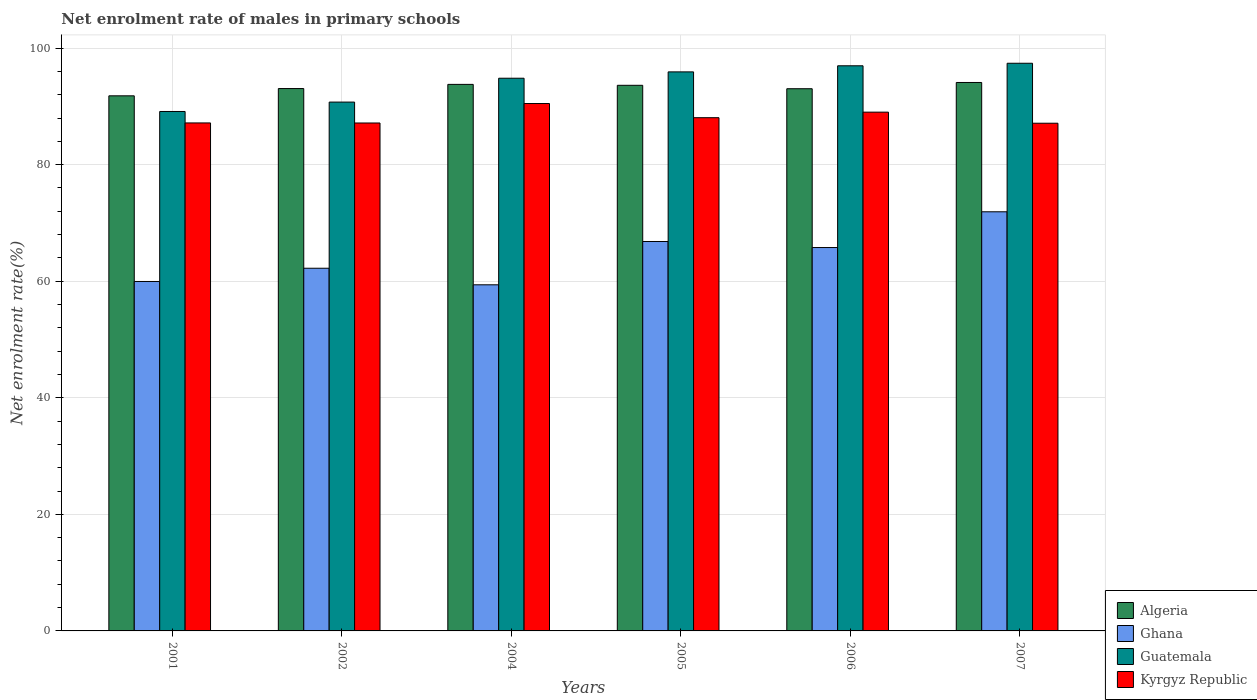How many groups of bars are there?
Make the answer very short. 6. Are the number of bars per tick equal to the number of legend labels?
Your answer should be compact. Yes. Are the number of bars on each tick of the X-axis equal?
Provide a short and direct response. Yes. How many bars are there on the 6th tick from the right?
Give a very brief answer. 4. What is the label of the 5th group of bars from the left?
Provide a short and direct response. 2006. In how many cases, is the number of bars for a given year not equal to the number of legend labels?
Ensure brevity in your answer.  0. What is the net enrolment rate of males in primary schools in Algeria in 2005?
Make the answer very short. 93.62. Across all years, what is the maximum net enrolment rate of males in primary schools in Algeria?
Make the answer very short. 94.11. Across all years, what is the minimum net enrolment rate of males in primary schools in Algeria?
Provide a short and direct response. 91.82. What is the total net enrolment rate of males in primary schools in Guatemala in the graph?
Give a very brief answer. 565. What is the difference between the net enrolment rate of males in primary schools in Kyrgyz Republic in 2004 and that in 2007?
Your answer should be compact. 3.38. What is the difference between the net enrolment rate of males in primary schools in Guatemala in 2001 and the net enrolment rate of males in primary schools in Kyrgyz Republic in 2004?
Your answer should be compact. -1.37. What is the average net enrolment rate of males in primary schools in Ghana per year?
Your answer should be very brief. 64.35. In the year 2004, what is the difference between the net enrolment rate of males in primary schools in Algeria and net enrolment rate of males in primary schools in Kyrgyz Republic?
Give a very brief answer. 3.28. What is the ratio of the net enrolment rate of males in primary schools in Algeria in 2002 to that in 2005?
Your answer should be compact. 0.99. Is the net enrolment rate of males in primary schools in Kyrgyz Republic in 2001 less than that in 2006?
Keep it short and to the point. Yes. Is the difference between the net enrolment rate of males in primary schools in Algeria in 2006 and 2007 greater than the difference between the net enrolment rate of males in primary schools in Kyrgyz Republic in 2006 and 2007?
Your answer should be compact. No. What is the difference between the highest and the second highest net enrolment rate of males in primary schools in Ghana?
Your response must be concise. 5.09. What is the difference between the highest and the lowest net enrolment rate of males in primary schools in Kyrgyz Republic?
Offer a terse response. 3.38. In how many years, is the net enrolment rate of males in primary schools in Ghana greater than the average net enrolment rate of males in primary schools in Ghana taken over all years?
Your response must be concise. 3. Is the sum of the net enrolment rate of males in primary schools in Algeria in 2001 and 2006 greater than the maximum net enrolment rate of males in primary schools in Kyrgyz Republic across all years?
Ensure brevity in your answer.  Yes. Is it the case that in every year, the sum of the net enrolment rate of males in primary schools in Guatemala and net enrolment rate of males in primary schools in Algeria is greater than the sum of net enrolment rate of males in primary schools in Kyrgyz Republic and net enrolment rate of males in primary schools in Ghana?
Your answer should be very brief. Yes. What does the 4th bar from the left in 2004 represents?
Your response must be concise. Kyrgyz Republic. What does the 2nd bar from the right in 2006 represents?
Make the answer very short. Guatemala. Is it the case that in every year, the sum of the net enrolment rate of males in primary schools in Algeria and net enrolment rate of males in primary schools in Guatemala is greater than the net enrolment rate of males in primary schools in Kyrgyz Republic?
Make the answer very short. Yes. How many bars are there?
Keep it short and to the point. 24. How many years are there in the graph?
Provide a short and direct response. 6. What is the difference between two consecutive major ticks on the Y-axis?
Ensure brevity in your answer.  20. Does the graph contain any zero values?
Your answer should be very brief. No. Where does the legend appear in the graph?
Ensure brevity in your answer.  Bottom right. How are the legend labels stacked?
Offer a very short reply. Vertical. What is the title of the graph?
Keep it short and to the point. Net enrolment rate of males in primary schools. Does "Vanuatu" appear as one of the legend labels in the graph?
Offer a terse response. No. What is the label or title of the Y-axis?
Give a very brief answer. Net enrolment rate(%). What is the Net enrolment rate(%) in Algeria in 2001?
Give a very brief answer. 91.82. What is the Net enrolment rate(%) in Ghana in 2001?
Offer a very short reply. 59.96. What is the Net enrolment rate(%) of Guatemala in 2001?
Keep it short and to the point. 89.13. What is the Net enrolment rate(%) in Kyrgyz Republic in 2001?
Provide a succinct answer. 87.16. What is the Net enrolment rate(%) in Algeria in 2002?
Offer a terse response. 93.06. What is the Net enrolment rate(%) of Ghana in 2002?
Ensure brevity in your answer.  62.23. What is the Net enrolment rate(%) in Guatemala in 2002?
Provide a succinct answer. 90.74. What is the Net enrolment rate(%) of Kyrgyz Republic in 2002?
Offer a very short reply. 87.15. What is the Net enrolment rate(%) of Algeria in 2004?
Make the answer very short. 93.78. What is the Net enrolment rate(%) in Ghana in 2004?
Make the answer very short. 59.39. What is the Net enrolment rate(%) of Guatemala in 2004?
Offer a very short reply. 94.83. What is the Net enrolment rate(%) of Kyrgyz Republic in 2004?
Provide a short and direct response. 90.5. What is the Net enrolment rate(%) of Algeria in 2005?
Give a very brief answer. 93.62. What is the Net enrolment rate(%) of Ghana in 2005?
Offer a terse response. 66.82. What is the Net enrolment rate(%) of Guatemala in 2005?
Keep it short and to the point. 95.92. What is the Net enrolment rate(%) in Kyrgyz Republic in 2005?
Your answer should be compact. 88.06. What is the Net enrolment rate(%) of Algeria in 2006?
Provide a short and direct response. 93.03. What is the Net enrolment rate(%) in Ghana in 2006?
Provide a short and direct response. 65.78. What is the Net enrolment rate(%) in Guatemala in 2006?
Ensure brevity in your answer.  96.97. What is the Net enrolment rate(%) in Kyrgyz Republic in 2006?
Your answer should be compact. 89.01. What is the Net enrolment rate(%) of Algeria in 2007?
Keep it short and to the point. 94.11. What is the Net enrolment rate(%) in Ghana in 2007?
Your answer should be very brief. 71.92. What is the Net enrolment rate(%) in Guatemala in 2007?
Offer a terse response. 97.4. What is the Net enrolment rate(%) of Kyrgyz Republic in 2007?
Make the answer very short. 87.11. Across all years, what is the maximum Net enrolment rate(%) in Algeria?
Your answer should be compact. 94.11. Across all years, what is the maximum Net enrolment rate(%) in Ghana?
Your answer should be very brief. 71.92. Across all years, what is the maximum Net enrolment rate(%) of Guatemala?
Your answer should be very brief. 97.4. Across all years, what is the maximum Net enrolment rate(%) in Kyrgyz Republic?
Your answer should be compact. 90.5. Across all years, what is the minimum Net enrolment rate(%) of Algeria?
Keep it short and to the point. 91.82. Across all years, what is the minimum Net enrolment rate(%) in Ghana?
Ensure brevity in your answer.  59.39. Across all years, what is the minimum Net enrolment rate(%) of Guatemala?
Ensure brevity in your answer.  89.13. Across all years, what is the minimum Net enrolment rate(%) of Kyrgyz Republic?
Make the answer very short. 87.11. What is the total Net enrolment rate(%) in Algeria in the graph?
Keep it short and to the point. 559.42. What is the total Net enrolment rate(%) in Ghana in the graph?
Provide a short and direct response. 386.1. What is the total Net enrolment rate(%) in Guatemala in the graph?
Ensure brevity in your answer.  565. What is the total Net enrolment rate(%) in Kyrgyz Republic in the graph?
Your answer should be very brief. 529. What is the difference between the Net enrolment rate(%) in Algeria in 2001 and that in 2002?
Your response must be concise. -1.25. What is the difference between the Net enrolment rate(%) of Ghana in 2001 and that in 2002?
Your answer should be very brief. -2.27. What is the difference between the Net enrolment rate(%) in Guatemala in 2001 and that in 2002?
Make the answer very short. -1.61. What is the difference between the Net enrolment rate(%) in Kyrgyz Republic in 2001 and that in 2002?
Your response must be concise. 0.01. What is the difference between the Net enrolment rate(%) of Algeria in 2001 and that in 2004?
Offer a terse response. -1.96. What is the difference between the Net enrolment rate(%) of Ghana in 2001 and that in 2004?
Provide a succinct answer. 0.57. What is the difference between the Net enrolment rate(%) in Guatemala in 2001 and that in 2004?
Provide a succinct answer. -5.71. What is the difference between the Net enrolment rate(%) of Kyrgyz Republic in 2001 and that in 2004?
Offer a very short reply. -3.33. What is the difference between the Net enrolment rate(%) in Algeria in 2001 and that in 2005?
Make the answer very short. -1.81. What is the difference between the Net enrolment rate(%) in Ghana in 2001 and that in 2005?
Offer a terse response. -6.86. What is the difference between the Net enrolment rate(%) in Guatemala in 2001 and that in 2005?
Offer a very short reply. -6.8. What is the difference between the Net enrolment rate(%) in Kyrgyz Republic in 2001 and that in 2005?
Keep it short and to the point. -0.9. What is the difference between the Net enrolment rate(%) of Algeria in 2001 and that in 2006?
Offer a very short reply. -1.22. What is the difference between the Net enrolment rate(%) in Ghana in 2001 and that in 2006?
Give a very brief answer. -5.82. What is the difference between the Net enrolment rate(%) of Guatemala in 2001 and that in 2006?
Your answer should be compact. -7.84. What is the difference between the Net enrolment rate(%) in Kyrgyz Republic in 2001 and that in 2006?
Offer a very short reply. -1.85. What is the difference between the Net enrolment rate(%) of Algeria in 2001 and that in 2007?
Your answer should be very brief. -2.29. What is the difference between the Net enrolment rate(%) in Ghana in 2001 and that in 2007?
Your answer should be compact. -11.96. What is the difference between the Net enrolment rate(%) of Guatemala in 2001 and that in 2007?
Ensure brevity in your answer.  -8.27. What is the difference between the Net enrolment rate(%) of Kyrgyz Republic in 2001 and that in 2007?
Give a very brief answer. 0.05. What is the difference between the Net enrolment rate(%) of Algeria in 2002 and that in 2004?
Provide a short and direct response. -0.72. What is the difference between the Net enrolment rate(%) of Ghana in 2002 and that in 2004?
Your response must be concise. 2.84. What is the difference between the Net enrolment rate(%) in Guatemala in 2002 and that in 2004?
Provide a succinct answer. -4.09. What is the difference between the Net enrolment rate(%) of Kyrgyz Republic in 2002 and that in 2004?
Your response must be concise. -3.34. What is the difference between the Net enrolment rate(%) of Algeria in 2002 and that in 2005?
Provide a succinct answer. -0.56. What is the difference between the Net enrolment rate(%) of Ghana in 2002 and that in 2005?
Your response must be concise. -4.59. What is the difference between the Net enrolment rate(%) in Guatemala in 2002 and that in 2005?
Your response must be concise. -5.18. What is the difference between the Net enrolment rate(%) of Kyrgyz Republic in 2002 and that in 2005?
Provide a succinct answer. -0.91. What is the difference between the Net enrolment rate(%) of Algeria in 2002 and that in 2006?
Provide a succinct answer. 0.03. What is the difference between the Net enrolment rate(%) of Ghana in 2002 and that in 2006?
Offer a very short reply. -3.55. What is the difference between the Net enrolment rate(%) in Guatemala in 2002 and that in 2006?
Make the answer very short. -6.23. What is the difference between the Net enrolment rate(%) of Kyrgyz Republic in 2002 and that in 2006?
Give a very brief answer. -1.86. What is the difference between the Net enrolment rate(%) of Algeria in 2002 and that in 2007?
Ensure brevity in your answer.  -1.04. What is the difference between the Net enrolment rate(%) in Ghana in 2002 and that in 2007?
Offer a very short reply. -9.68. What is the difference between the Net enrolment rate(%) in Guatemala in 2002 and that in 2007?
Give a very brief answer. -6.66. What is the difference between the Net enrolment rate(%) in Kyrgyz Republic in 2002 and that in 2007?
Your answer should be very brief. 0.04. What is the difference between the Net enrolment rate(%) of Algeria in 2004 and that in 2005?
Give a very brief answer. 0.16. What is the difference between the Net enrolment rate(%) in Ghana in 2004 and that in 2005?
Ensure brevity in your answer.  -7.43. What is the difference between the Net enrolment rate(%) in Guatemala in 2004 and that in 2005?
Provide a succinct answer. -1.09. What is the difference between the Net enrolment rate(%) in Kyrgyz Republic in 2004 and that in 2005?
Your answer should be very brief. 2.43. What is the difference between the Net enrolment rate(%) of Algeria in 2004 and that in 2006?
Provide a short and direct response. 0.75. What is the difference between the Net enrolment rate(%) in Ghana in 2004 and that in 2006?
Make the answer very short. -6.39. What is the difference between the Net enrolment rate(%) in Guatemala in 2004 and that in 2006?
Provide a short and direct response. -2.14. What is the difference between the Net enrolment rate(%) of Kyrgyz Republic in 2004 and that in 2006?
Your response must be concise. 1.48. What is the difference between the Net enrolment rate(%) in Algeria in 2004 and that in 2007?
Provide a succinct answer. -0.33. What is the difference between the Net enrolment rate(%) in Ghana in 2004 and that in 2007?
Your response must be concise. -12.53. What is the difference between the Net enrolment rate(%) of Guatemala in 2004 and that in 2007?
Offer a terse response. -2.57. What is the difference between the Net enrolment rate(%) in Kyrgyz Republic in 2004 and that in 2007?
Keep it short and to the point. 3.38. What is the difference between the Net enrolment rate(%) of Algeria in 2005 and that in 2006?
Offer a very short reply. 0.59. What is the difference between the Net enrolment rate(%) of Ghana in 2005 and that in 2006?
Give a very brief answer. 1.04. What is the difference between the Net enrolment rate(%) in Guatemala in 2005 and that in 2006?
Your answer should be compact. -1.05. What is the difference between the Net enrolment rate(%) in Kyrgyz Republic in 2005 and that in 2006?
Your answer should be compact. -0.95. What is the difference between the Net enrolment rate(%) in Algeria in 2005 and that in 2007?
Offer a terse response. -0.48. What is the difference between the Net enrolment rate(%) of Ghana in 2005 and that in 2007?
Make the answer very short. -5.09. What is the difference between the Net enrolment rate(%) in Guatemala in 2005 and that in 2007?
Provide a short and direct response. -1.48. What is the difference between the Net enrolment rate(%) of Kyrgyz Republic in 2005 and that in 2007?
Make the answer very short. 0.95. What is the difference between the Net enrolment rate(%) in Algeria in 2006 and that in 2007?
Your answer should be compact. -1.07. What is the difference between the Net enrolment rate(%) in Ghana in 2006 and that in 2007?
Your response must be concise. -6.13. What is the difference between the Net enrolment rate(%) in Guatemala in 2006 and that in 2007?
Your answer should be very brief. -0.43. What is the difference between the Net enrolment rate(%) of Kyrgyz Republic in 2006 and that in 2007?
Make the answer very short. 1.9. What is the difference between the Net enrolment rate(%) in Algeria in 2001 and the Net enrolment rate(%) in Ghana in 2002?
Keep it short and to the point. 29.58. What is the difference between the Net enrolment rate(%) of Algeria in 2001 and the Net enrolment rate(%) of Guatemala in 2002?
Your answer should be very brief. 1.07. What is the difference between the Net enrolment rate(%) in Algeria in 2001 and the Net enrolment rate(%) in Kyrgyz Republic in 2002?
Provide a short and direct response. 4.66. What is the difference between the Net enrolment rate(%) of Ghana in 2001 and the Net enrolment rate(%) of Guatemala in 2002?
Ensure brevity in your answer.  -30.78. What is the difference between the Net enrolment rate(%) in Ghana in 2001 and the Net enrolment rate(%) in Kyrgyz Republic in 2002?
Offer a terse response. -27.19. What is the difference between the Net enrolment rate(%) of Guatemala in 2001 and the Net enrolment rate(%) of Kyrgyz Republic in 2002?
Your answer should be compact. 1.97. What is the difference between the Net enrolment rate(%) in Algeria in 2001 and the Net enrolment rate(%) in Ghana in 2004?
Provide a short and direct response. 32.43. What is the difference between the Net enrolment rate(%) of Algeria in 2001 and the Net enrolment rate(%) of Guatemala in 2004?
Your answer should be very brief. -3.02. What is the difference between the Net enrolment rate(%) in Algeria in 2001 and the Net enrolment rate(%) in Kyrgyz Republic in 2004?
Give a very brief answer. 1.32. What is the difference between the Net enrolment rate(%) in Ghana in 2001 and the Net enrolment rate(%) in Guatemala in 2004?
Ensure brevity in your answer.  -34.87. What is the difference between the Net enrolment rate(%) of Ghana in 2001 and the Net enrolment rate(%) of Kyrgyz Republic in 2004?
Keep it short and to the point. -30.53. What is the difference between the Net enrolment rate(%) in Guatemala in 2001 and the Net enrolment rate(%) in Kyrgyz Republic in 2004?
Provide a short and direct response. -1.37. What is the difference between the Net enrolment rate(%) of Algeria in 2001 and the Net enrolment rate(%) of Ghana in 2005?
Provide a short and direct response. 24.99. What is the difference between the Net enrolment rate(%) of Algeria in 2001 and the Net enrolment rate(%) of Guatemala in 2005?
Your answer should be very brief. -4.11. What is the difference between the Net enrolment rate(%) in Algeria in 2001 and the Net enrolment rate(%) in Kyrgyz Republic in 2005?
Make the answer very short. 3.75. What is the difference between the Net enrolment rate(%) of Ghana in 2001 and the Net enrolment rate(%) of Guatemala in 2005?
Your response must be concise. -35.96. What is the difference between the Net enrolment rate(%) of Ghana in 2001 and the Net enrolment rate(%) of Kyrgyz Republic in 2005?
Your answer should be very brief. -28.1. What is the difference between the Net enrolment rate(%) of Guatemala in 2001 and the Net enrolment rate(%) of Kyrgyz Republic in 2005?
Give a very brief answer. 1.06. What is the difference between the Net enrolment rate(%) of Algeria in 2001 and the Net enrolment rate(%) of Ghana in 2006?
Keep it short and to the point. 26.03. What is the difference between the Net enrolment rate(%) in Algeria in 2001 and the Net enrolment rate(%) in Guatemala in 2006?
Your answer should be very brief. -5.15. What is the difference between the Net enrolment rate(%) of Algeria in 2001 and the Net enrolment rate(%) of Kyrgyz Republic in 2006?
Provide a short and direct response. 2.8. What is the difference between the Net enrolment rate(%) in Ghana in 2001 and the Net enrolment rate(%) in Guatemala in 2006?
Keep it short and to the point. -37.01. What is the difference between the Net enrolment rate(%) in Ghana in 2001 and the Net enrolment rate(%) in Kyrgyz Republic in 2006?
Give a very brief answer. -29.05. What is the difference between the Net enrolment rate(%) of Guatemala in 2001 and the Net enrolment rate(%) of Kyrgyz Republic in 2006?
Your response must be concise. 0.11. What is the difference between the Net enrolment rate(%) of Algeria in 2001 and the Net enrolment rate(%) of Ghana in 2007?
Keep it short and to the point. 19.9. What is the difference between the Net enrolment rate(%) in Algeria in 2001 and the Net enrolment rate(%) in Guatemala in 2007?
Offer a terse response. -5.59. What is the difference between the Net enrolment rate(%) in Algeria in 2001 and the Net enrolment rate(%) in Kyrgyz Republic in 2007?
Your response must be concise. 4.7. What is the difference between the Net enrolment rate(%) in Ghana in 2001 and the Net enrolment rate(%) in Guatemala in 2007?
Ensure brevity in your answer.  -37.44. What is the difference between the Net enrolment rate(%) in Ghana in 2001 and the Net enrolment rate(%) in Kyrgyz Republic in 2007?
Your answer should be very brief. -27.15. What is the difference between the Net enrolment rate(%) of Guatemala in 2001 and the Net enrolment rate(%) of Kyrgyz Republic in 2007?
Offer a terse response. 2.02. What is the difference between the Net enrolment rate(%) of Algeria in 2002 and the Net enrolment rate(%) of Ghana in 2004?
Your response must be concise. 33.67. What is the difference between the Net enrolment rate(%) in Algeria in 2002 and the Net enrolment rate(%) in Guatemala in 2004?
Make the answer very short. -1.77. What is the difference between the Net enrolment rate(%) in Algeria in 2002 and the Net enrolment rate(%) in Kyrgyz Republic in 2004?
Your response must be concise. 2.57. What is the difference between the Net enrolment rate(%) of Ghana in 2002 and the Net enrolment rate(%) of Guatemala in 2004?
Provide a succinct answer. -32.6. What is the difference between the Net enrolment rate(%) in Ghana in 2002 and the Net enrolment rate(%) in Kyrgyz Republic in 2004?
Offer a very short reply. -28.26. What is the difference between the Net enrolment rate(%) of Guatemala in 2002 and the Net enrolment rate(%) of Kyrgyz Republic in 2004?
Your response must be concise. 0.25. What is the difference between the Net enrolment rate(%) of Algeria in 2002 and the Net enrolment rate(%) of Ghana in 2005?
Give a very brief answer. 26.24. What is the difference between the Net enrolment rate(%) of Algeria in 2002 and the Net enrolment rate(%) of Guatemala in 2005?
Your response must be concise. -2.86. What is the difference between the Net enrolment rate(%) of Algeria in 2002 and the Net enrolment rate(%) of Kyrgyz Republic in 2005?
Offer a very short reply. 5. What is the difference between the Net enrolment rate(%) in Ghana in 2002 and the Net enrolment rate(%) in Guatemala in 2005?
Keep it short and to the point. -33.69. What is the difference between the Net enrolment rate(%) of Ghana in 2002 and the Net enrolment rate(%) of Kyrgyz Republic in 2005?
Keep it short and to the point. -25.83. What is the difference between the Net enrolment rate(%) of Guatemala in 2002 and the Net enrolment rate(%) of Kyrgyz Republic in 2005?
Your response must be concise. 2.68. What is the difference between the Net enrolment rate(%) of Algeria in 2002 and the Net enrolment rate(%) of Ghana in 2006?
Your answer should be compact. 27.28. What is the difference between the Net enrolment rate(%) in Algeria in 2002 and the Net enrolment rate(%) in Guatemala in 2006?
Give a very brief answer. -3.91. What is the difference between the Net enrolment rate(%) in Algeria in 2002 and the Net enrolment rate(%) in Kyrgyz Republic in 2006?
Offer a terse response. 4.05. What is the difference between the Net enrolment rate(%) in Ghana in 2002 and the Net enrolment rate(%) in Guatemala in 2006?
Your response must be concise. -34.74. What is the difference between the Net enrolment rate(%) in Ghana in 2002 and the Net enrolment rate(%) in Kyrgyz Republic in 2006?
Offer a terse response. -26.78. What is the difference between the Net enrolment rate(%) in Guatemala in 2002 and the Net enrolment rate(%) in Kyrgyz Republic in 2006?
Keep it short and to the point. 1.73. What is the difference between the Net enrolment rate(%) in Algeria in 2002 and the Net enrolment rate(%) in Ghana in 2007?
Keep it short and to the point. 21.15. What is the difference between the Net enrolment rate(%) in Algeria in 2002 and the Net enrolment rate(%) in Guatemala in 2007?
Give a very brief answer. -4.34. What is the difference between the Net enrolment rate(%) of Algeria in 2002 and the Net enrolment rate(%) of Kyrgyz Republic in 2007?
Provide a short and direct response. 5.95. What is the difference between the Net enrolment rate(%) in Ghana in 2002 and the Net enrolment rate(%) in Guatemala in 2007?
Your answer should be compact. -35.17. What is the difference between the Net enrolment rate(%) in Ghana in 2002 and the Net enrolment rate(%) in Kyrgyz Republic in 2007?
Offer a very short reply. -24.88. What is the difference between the Net enrolment rate(%) of Guatemala in 2002 and the Net enrolment rate(%) of Kyrgyz Republic in 2007?
Offer a very short reply. 3.63. What is the difference between the Net enrolment rate(%) of Algeria in 2004 and the Net enrolment rate(%) of Ghana in 2005?
Your answer should be compact. 26.96. What is the difference between the Net enrolment rate(%) in Algeria in 2004 and the Net enrolment rate(%) in Guatemala in 2005?
Provide a succinct answer. -2.14. What is the difference between the Net enrolment rate(%) of Algeria in 2004 and the Net enrolment rate(%) of Kyrgyz Republic in 2005?
Keep it short and to the point. 5.72. What is the difference between the Net enrolment rate(%) of Ghana in 2004 and the Net enrolment rate(%) of Guatemala in 2005?
Give a very brief answer. -36.53. What is the difference between the Net enrolment rate(%) of Ghana in 2004 and the Net enrolment rate(%) of Kyrgyz Republic in 2005?
Make the answer very short. -28.67. What is the difference between the Net enrolment rate(%) of Guatemala in 2004 and the Net enrolment rate(%) of Kyrgyz Republic in 2005?
Ensure brevity in your answer.  6.77. What is the difference between the Net enrolment rate(%) of Algeria in 2004 and the Net enrolment rate(%) of Ghana in 2006?
Make the answer very short. 28. What is the difference between the Net enrolment rate(%) in Algeria in 2004 and the Net enrolment rate(%) in Guatemala in 2006?
Offer a terse response. -3.19. What is the difference between the Net enrolment rate(%) in Algeria in 2004 and the Net enrolment rate(%) in Kyrgyz Republic in 2006?
Ensure brevity in your answer.  4.77. What is the difference between the Net enrolment rate(%) in Ghana in 2004 and the Net enrolment rate(%) in Guatemala in 2006?
Provide a short and direct response. -37.58. What is the difference between the Net enrolment rate(%) of Ghana in 2004 and the Net enrolment rate(%) of Kyrgyz Republic in 2006?
Provide a short and direct response. -29.62. What is the difference between the Net enrolment rate(%) of Guatemala in 2004 and the Net enrolment rate(%) of Kyrgyz Republic in 2006?
Ensure brevity in your answer.  5.82. What is the difference between the Net enrolment rate(%) in Algeria in 2004 and the Net enrolment rate(%) in Ghana in 2007?
Make the answer very short. 21.86. What is the difference between the Net enrolment rate(%) in Algeria in 2004 and the Net enrolment rate(%) in Guatemala in 2007?
Provide a short and direct response. -3.62. What is the difference between the Net enrolment rate(%) of Ghana in 2004 and the Net enrolment rate(%) of Guatemala in 2007?
Provide a short and direct response. -38.01. What is the difference between the Net enrolment rate(%) of Ghana in 2004 and the Net enrolment rate(%) of Kyrgyz Republic in 2007?
Make the answer very short. -27.72. What is the difference between the Net enrolment rate(%) in Guatemala in 2004 and the Net enrolment rate(%) in Kyrgyz Republic in 2007?
Your answer should be very brief. 7.72. What is the difference between the Net enrolment rate(%) of Algeria in 2005 and the Net enrolment rate(%) of Ghana in 2006?
Provide a short and direct response. 27.84. What is the difference between the Net enrolment rate(%) in Algeria in 2005 and the Net enrolment rate(%) in Guatemala in 2006?
Ensure brevity in your answer.  -3.35. What is the difference between the Net enrolment rate(%) in Algeria in 2005 and the Net enrolment rate(%) in Kyrgyz Republic in 2006?
Keep it short and to the point. 4.61. What is the difference between the Net enrolment rate(%) in Ghana in 2005 and the Net enrolment rate(%) in Guatemala in 2006?
Keep it short and to the point. -30.15. What is the difference between the Net enrolment rate(%) in Ghana in 2005 and the Net enrolment rate(%) in Kyrgyz Republic in 2006?
Offer a very short reply. -22.19. What is the difference between the Net enrolment rate(%) in Guatemala in 2005 and the Net enrolment rate(%) in Kyrgyz Republic in 2006?
Give a very brief answer. 6.91. What is the difference between the Net enrolment rate(%) in Algeria in 2005 and the Net enrolment rate(%) in Ghana in 2007?
Provide a succinct answer. 21.7. What is the difference between the Net enrolment rate(%) of Algeria in 2005 and the Net enrolment rate(%) of Guatemala in 2007?
Your response must be concise. -3.78. What is the difference between the Net enrolment rate(%) of Algeria in 2005 and the Net enrolment rate(%) of Kyrgyz Republic in 2007?
Your response must be concise. 6.51. What is the difference between the Net enrolment rate(%) of Ghana in 2005 and the Net enrolment rate(%) of Guatemala in 2007?
Ensure brevity in your answer.  -30.58. What is the difference between the Net enrolment rate(%) of Ghana in 2005 and the Net enrolment rate(%) of Kyrgyz Republic in 2007?
Keep it short and to the point. -20.29. What is the difference between the Net enrolment rate(%) of Guatemala in 2005 and the Net enrolment rate(%) of Kyrgyz Republic in 2007?
Make the answer very short. 8.81. What is the difference between the Net enrolment rate(%) of Algeria in 2006 and the Net enrolment rate(%) of Ghana in 2007?
Keep it short and to the point. 21.12. What is the difference between the Net enrolment rate(%) of Algeria in 2006 and the Net enrolment rate(%) of Guatemala in 2007?
Your response must be concise. -4.37. What is the difference between the Net enrolment rate(%) of Algeria in 2006 and the Net enrolment rate(%) of Kyrgyz Republic in 2007?
Give a very brief answer. 5.92. What is the difference between the Net enrolment rate(%) in Ghana in 2006 and the Net enrolment rate(%) in Guatemala in 2007?
Give a very brief answer. -31.62. What is the difference between the Net enrolment rate(%) in Ghana in 2006 and the Net enrolment rate(%) in Kyrgyz Republic in 2007?
Provide a short and direct response. -21.33. What is the difference between the Net enrolment rate(%) in Guatemala in 2006 and the Net enrolment rate(%) in Kyrgyz Republic in 2007?
Provide a short and direct response. 9.86. What is the average Net enrolment rate(%) in Algeria per year?
Your answer should be very brief. 93.24. What is the average Net enrolment rate(%) in Ghana per year?
Make the answer very short. 64.35. What is the average Net enrolment rate(%) of Guatemala per year?
Your answer should be very brief. 94.17. What is the average Net enrolment rate(%) in Kyrgyz Republic per year?
Offer a terse response. 88.17. In the year 2001, what is the difference between the Net enrolment rate(%) of Algeria and Net enrolment rate(%) of Ghana?
Your answer should be very brief. 31.85. In the year 2001, what is the difference between the Net enrolment rate(%) of Algeria and Net enrolment rate(%) of Guatemala?
Make the answer very short. 2.69. In the year 2001, what is the difference between the Net enrolment rate(%) of Algeria and Net enrolment rate(%) of Kyrgyz Republic?
Your answer should be compact. 4.65. In the year 2001, what is the difference between the Net enrolment rate(%) of Ghana and Net enrolment rate(%) of Guatemala?
Provide a succinct answer. -29.17. In the year 2001, what is the difference between the Net enrolment rate(%) in Ghana and Net enrolment rate(%) in Kyrgyz Republic?
Keep it short and to the point. -27.2. In the year 2001, what is the difference between the Net enrolment rate(%) of Guatemala and Net enrolment rate(%) of Kyrgyz Republic?
Make the answer very short. 1.96. In the year 2002, what is the difference between the Net enrolment rate(%) in Algeria and Net enrolment rate(%) in Ghana?
Provide a short and direct response. 30.83. In the year 2002, what is the difference between the Net enrolment rate(%) of Algeria and Net enrolment rate(%) of Guatemala?
Offer a terse response. 2.32. In the year 2002, what is the difference between the Net enrolment rate(%) in Algeria and Net enrolment rate(%) in Kyrgyz Republic?
Keep it short and to the point. 5.91. In the year 2002, what is the difference between the Net enrolment rate(%) of Ghana and Net enrolment rate(%) of Guatemala?
Offer a terse response. -28.51. In the year 2002, what is the difference between the Net enrolment rate(%) in Ghana and Net enrolment rate(%) in Kyrgyz Republic?
Make the answer very short. -24.92. In the year 2002, what is the difference between the Net enrolment rate(%) in Guatemala and Net enrolment rate(%) in Kyrgyz Republic?
Your response must be concise. 3.59. In the year 2004, what is the difference between the Net enrolment rate(%) in Algeria and Net enrolment rate(%) in Ghana?
Your response must be concise. 34.39. In the year 2004, what is the difference between the Net enrolment rate(%) in Algeria and Net enrolment rate(%) in Guatemala?
Ensure brevity in your answer.  -1.05. In the year 2004, what is the difference between the Net enrolment rate(%) in Algeria and Net enrolment rate(%) in Kyrgyz Republic?
Offer a terse response. 3.28. In the year 2004, what is the difference between the Net enrolment rate(%) in Ghana and Net enrolment rate(%) in Guatemala?
Your answer should be very brief. -35.44. In the year 2004, what is the difference between the Net enrolment rate(%) in Ghana and Net enrolment rate(%) in Kyrgyz Republic?
Ensure brevity in your answer.  -31.11. In the year 2004, what is the difference between the Net enrolment rate(%) in Guatemala and Net enrolment rate(%) in Kyrgyz Republic?
Give a very brief answer. 4.34. In the year 2005, what is the difference between the Net enrolment rate(%) in Algeria and Net enrolment rate(%) in Ghana?
Ensure brevity in your answer.  26.8. In the year 2005, what is the difference between the Net enrolment rate(%) of Algeria and Net enrolment rate(%) of Guatemala?
Keep it short and to the point. -2.3. In the year 2005, what is the difference between the Net enrolment rate(%) of Algeria and Net enrolment rate(%) of Kyrgyz Republic?
Provide a succinct answer. 5.56. In the year 2005, what is the difference between the Net enrolment rate(%) in Ghana and Net enrolment rate(%) in Guatemala?
Ensure brevity in your answer.  -29.1. In the year 2005, what is the difference between the Net enrolment rate(%) in Ghana and Net enrolment rate(%) in Kyrgyz Republic?
Offer a very short reply. -21.24. In the year 2005, what is the difference between the Net enrolment rate(%) of Guatemala and Net enrolment rate(%) of Kyrgyz Republic?
Offer a very short reply. 7.86. In the year 2006, what is the difference between the Net enrolment rate(%) of Algeria and Net enrolment rate(%) of Ghana?
Offer a very short reply. 27.25. In the year 2006, what is the difference between the Net enrolment rate(%) of Algeria and Net enrolment rate(%) of Guatemala?
Give a very brief answer. -3.94. In the year 2006, what is the difference between the Net enrolment rate(%) of Algeria and Net enrolment rate(%) of Kyrgyz Republic?
Make the answer very short. 4.02. In the year 2006, what is the difference between the Net enrolment rate(%) in Ghana and Net enrolment rate(%) in Guatemala?
Offer a very short reply. -31.19. In the year 2006, what is the difference between the Net enrolment rate(%) in Ghana and Net enrolment rate(%) in Kyrgyz Republic?
Your answer should be compact. -23.23. In the year 2006, what is the difference between the Net enrolment rate(%) of Guatemala and Net enrolment rate(%) of Kyrgyz Republic?
Ensure brevity in your answer.  7.96. In the year 2007, what is the difference between the Net enrolment rate(%) in Algeria and Net enrolment rate(%) in Ghana?
Give a very brief answer. 22.19. In the year 2007, what is the difference between the Net enrolment rate(%) of Algeria and Net enrolment rate(%) of Guatemala?
Make the answer very short. -3.3. In the year 2007, what is the difference between the Net enrolment rate(%) of Algeria and Net enrolment rate(%) of Kyrgyz Republic?
Offer a very short reply. 6.99. In the year 2007, what is the difference between the Net enrolment rate(%) of Ghana and Net enrolment rate(%) of Guatemala?
Ensure brevity in your answer.  -25.49. In the year 2007, what is the difference between the Net enrolment rate(%) of Ghana and Net enrolment rate(%) of Kyrgyz Republic?
Your answer should be very brief. -15.2. In the year 2007, what is the difference between the Net enrolment rate(%) of Guatemala and Net enrolment rate(%) of Kyrgyz Republic?
Ensure brevity in your answer.  10.29. What is the ratio of the Net enrolment rate(%) of Algeria in 2001 to that in 2002?
Offer a terse response. 0.99. What is the ratio of the Net enrolment rate(%) in Ghana in 2001 to that in 2002?
Offer a very short reply. 0.96. What is the ratio of the Net enrolment rate(%) of Guatemala in 2001 to that in 2002?
Make the answer very short. 0.98. What is the ratio of the Net enrolment rate(%) of Algeria in 2001 to that in 2004?
Offer a very short reply. 0.98. What is the ratio of the Net enrolment rate(%) of Ghana in 2001 to that in 2004?
Give a very brief answer. 1.01. What is the ratio of the Net enrolment rate(%) in Guatemala in 2001 to that in 2004?
Provide a short and direct response. 0.94. What is the ratio of the Net enrolment rate(%) of Kyrgyz Republic in 2001 to that in 2004?
Provide a succinct answer. 0.96. What is the ratio of the Net enrolment rate(%) of Algeria in 2001 to that in 2005?
Make the answer very short. 0.98. What is the ratio of the Net enrolment rate(%) in Ghana in 2001 to that in 2005?
Your response must be concise. 0.9. What is the ratio of the Net enrolment rate(%) of Guatemala in 2001 to that in 2005?
Provide a short and direct response. 0.93. What is the ratio of the Net enrolment rate(%) of Kyrgyz Republic in 2001 to that in 2005?
Offer a terse response. 0.99. What is the ratio of the Net enrolment rate(%) of Algeria in 2001 to that in 2006?
Keep it short and to the point. 0.99. What is the ratio of the Net enrolment rate(%) in Ghana in 2001 to that in 2006?
Make the answer very short. 0.91. What is the ratio of the Net enrolment rate(%) in Guatemala in 2001 to that in 2006?
Provide a succinct answer. 0.92. What is the ratio of the Net enrolment rate(%) in Kyrgyz Republic in 2001 to that in 2006?
Provide a short and direct response. 0.98. What is the ratio of the Net enrolment rate(%) of Algeria in 2001 to that in 2007?
Provide a succinct answer. 0.98. What is the ratio of the Net enrolment rate(%) in Ghana in 2001 to that in 2007?
Your response must be concise. 0.83. What is the ratio of the Net enrolment rate(%) in Guatemala in 2001 to that in 2007?
Your answer should be compact. 0.92. What is the ratio of the Net enrolment rate(%) in Algeria in 2002 to that in 2004?
Ensure brevity in your answer.  0.99. What is the ratio of the Net enrolment rate(%) of Ghana in 2002 to that in 2004?
Offer a terse response. 1.05. What is the ratio of the Net enrolment rate(%) in Guatemala in 2002 to that in 2004?
Your answer should be very brief. 0.96. What is the ratio of the Net enrolment rate(%) of Kyrgyz Republic in 2002 to that in 2004?
Make the answer very short. 0.96. What is the ratio of the Net enrolment rate(%) of Ghana in 2002 to that in 2005?
Offer a very short reply. 0.93. What is the ratio of the Net enrolment rate(%) of Guatemala in 2002 to that in 2005?
Make the answer very short. 0.95. What is the ratio of the Net enrolment rate(%) in Kyrgyz Republic in 2002 to that in 2005?
Make the answer very short. 0.99. What is the ratio of the Net enrolment rate(%) in Ghana in 2002 to that in 2006?
Offer a very short reply. 0.95. What is the ratio of the Net enrolment rate(%) of Guatemala in 2002 to that in 2006?
Offer a very short reply. 0.94. What is the ratio of the Net enrolment rate(%) of Kyrgyz Republic in 2002 to that in 2006?
Make the answer very short. 0.98. What is the ratio of the Net enrolment rate(%) of Algeria in 2002 to that in 2007?
Your answer should be compact. 0.99. What is the ratio of the Net enrolment rate(%) in Ghana in 2002 to that in 2007?
Your answer should be very brief. 0.87. What is the ratio of the Net enrolment rate(%) of Guatemala in 2002 to that in 2007?
Your answer should be very brief. 0.93. What is the ratio of the Net enrolment rate(%) of Algeria in 2004 to that in 2005?
Make the answer very short. 1. What is the ratio of the Net enrolment rate(%) in Ghana in 2004 to that in 2005?
Your answer should be very brief. 0.89. What is the ratio of the Net enrolment rate(%) of Kyrgyz Republic in 2004 to that in 2005?
Provide a succinct answer. 1.03. What is the ratio of the Net enrolment rate(%) in Ghana in 2004 to that in 2006?
Your answer should be very brief. 0.9. What is the ratio of the Net enrolment rate(%) in Guatemala in 2004 to that in 2006?
Give a very brief answer. 0.98. What is the ratio of the Net enrolment rate(%) of Kyrgyz Republic in 2004 to that in 2006?
Ensure brevity in your answer.  1.02. What is the ratio of the Net enrolment rate(%) in Ghana in 2004 to that in 2007?
Your answer should be very brief. 0.83. What is the ratio of the Net enrolment rate(%) of Guatemala in 2004 to that in 2007?
Provide a short and direct response. 0.97. What is the ratio of the Net enrolment rate(%) in Kyrgyz Republic in 2004 to that in 2007?
Give a very brief answer. 1.04. What is the ratio of the Net enrolment rate(%) of Ghana in 2005 to that in 2006?
Provide a short and direct response. 1.02. What is the ratio of the Net enrolment rate(%) of Kyrgyz Republic in 2005 to that in 2006?
Your answer should be compact. 0.99. What is the ratio of the Net enrolment rate(%) of Algeria in 2005 to that in 2007?
Provide a succinct answer. 0.99. What is the ratio of the Net enrolment rate(%) of Ghana in 2005 to that in 2007?
Your response must be concise. 0.93. What is the ratio of the Net enrolment rate(%) in Guatemala in 2005 to that in 2007?
Your answer should be compact. 0.98. What is the ratio of the Net enrolment rate(%) in Kyrgyz Republic in 2005 to that in 2007?
Provide a succinct answer. 1.01. What is the ratio of the Net enrolment rate(%) of Algeria in 2006 to that in 2007?
Your answer should be compact. 0.99. What is the ratio of the Net enrolment rate(%) in Ghana in 2006 to that in 2007?
Provide a short and direct response. 0.91. What is the ratio of the Net enrolment rate(%) of Kyrgyz Republic in 2006 to that in 2007?
Your response must be concise. 1.02. What is the difference between the highest and the second highest Net enrolment rate(%) in Algeria?
Offer a very short reply. 0.33. What is the difference between the highest and the second highest Net enrolment rate(%) of Ghana?
Keep it short and to the point. 5.09. What is the difference between the highest and the second highest Net enrolment rate(%) in Guatemala?
Offer a very short reply. 0.43. What is the difference between the highest and the second highest Net enrolment rate(%) of Kyrgyz Republic?
Your response must be concise. 1.48. What is the difference between the highest and the lowest Net enrolment rate(%) in Algeria?
Ensure brevity in your answer.  2.29. What is the difference between the highest and the lowest Net enrolment rate(%) in Ghana?
Offer a terse response. 12.53. What is the difference between the highest and the lowest Net enrolment rate(%) in Guatemala?
Offer a terse response. 8.27. What is the difference between the highest and the lowest Net enrolment rate(%) of Kyrgyz Republic?
Your answer should be very brief. 3.38. 